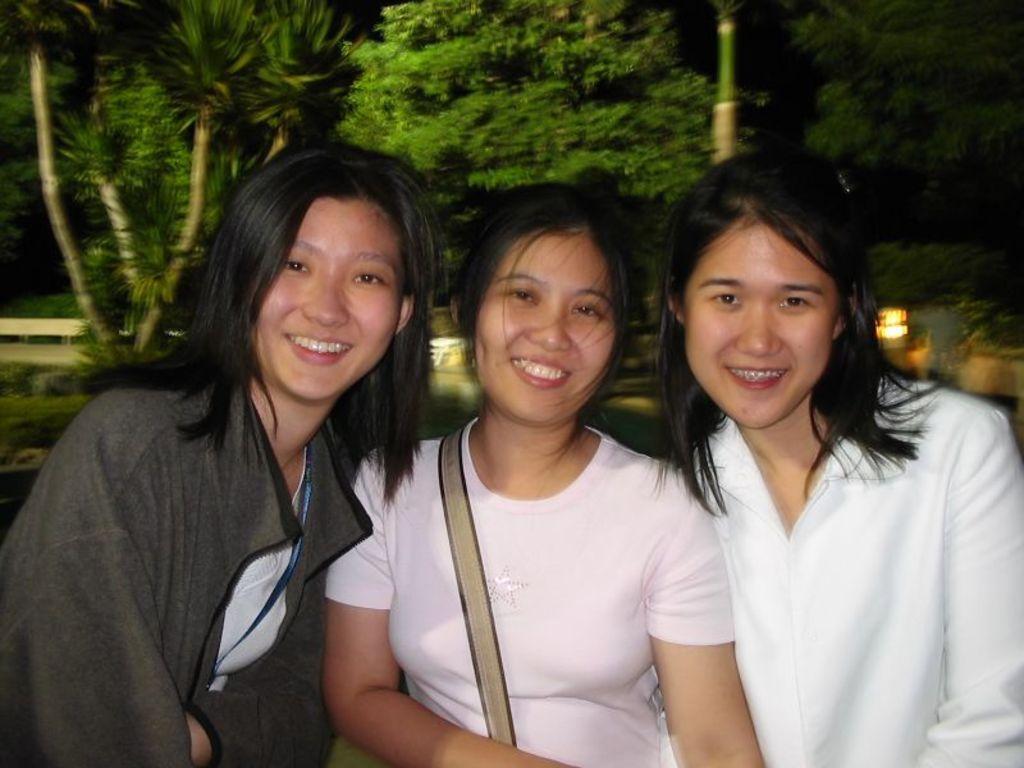Describe this image in one or two sentences. In this image we can see three ladies, behind them, there are trees, plants, and a light. 